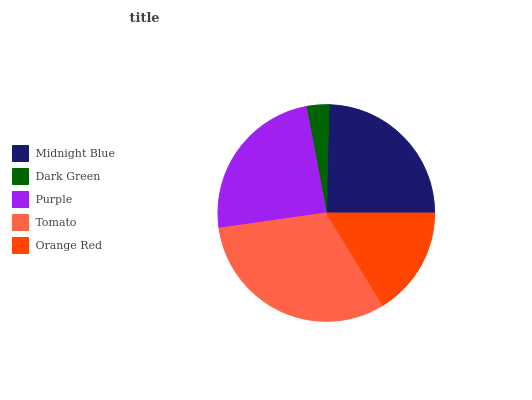Is Dark Green the minimum?
Answer yes or no. Yes. Is Tomato the maximum?
Answer yes or no. Yes. Is Purple the minimum?
Answer yes or no. No. Is Purple the maximum?
Answer yes or no. No. Is Purple greater than Dark Green?
Answer yes or no. Yes. Is Dark Green less than Purple?
Answer yes or no. Yes. Is Dark Green greater than Purple?
Answer yes or no. No. Is Purple less than Dark Green?
Answer yes or no. No. Is Purple the high median?
Answer yes or no. Yes. Is Purple the low median?
Answer yes or no. Yes. Is Dark Green the high median?
Answer yes or no. No. Is Midnight Blue the low median?
Answer yes or no. No. 